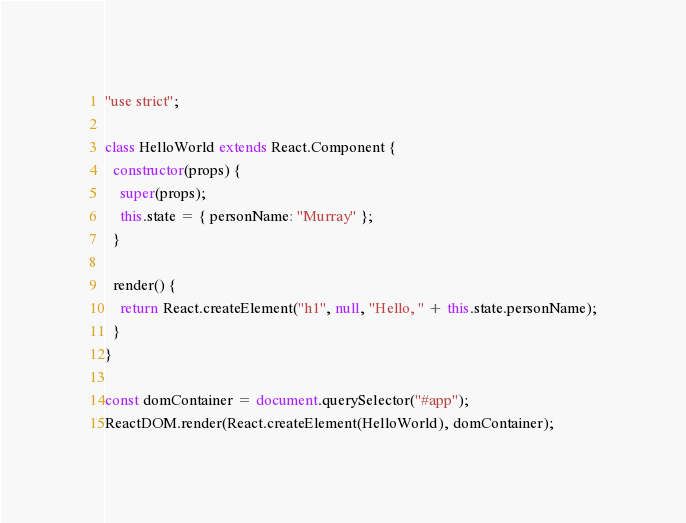Convert code to text. <code><loc_0><loc_0><loc_500><loc_500><_JavaScript_>"use strict";

class HelloWorld extends React.Component {
  constructor(props) {
    super(props);
    this.state = { personName: "Murray" };
  }

  render() {
    return React.createElement("h1", null, "Hello, " + this.state.personName);
  }
}

const domContainer = document.querySelector("#app");
ReactDOM.render(React.createElement(HelloWorld), domContainer);
</code> 